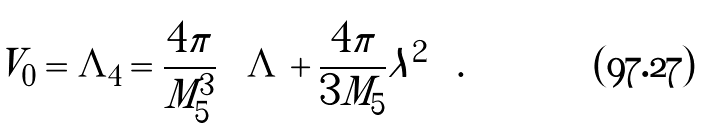<formula> <loc_0><loc_0><loc_500><loc_500>V _ { 0 } = \Lambda _ { 4 } = \frac { 4 \pi } { M ^ { 3 } _ { 5 } } \left ( \Lambda + \frac { 4 \pi } { 3 M _ { 5 } } \lambda ^ { 2 } \right ) .</formula> 